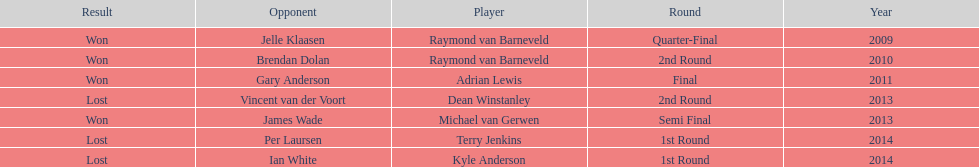What was the names of all the players? Raymond van Barneveld, Raymond van Barneveld, Adrian Lewis, Dean Winstanley, Michael van Gerwen, Terry Jenkins, Kyle Anderson. What years were the championship offered? 2009, 2010, 2011, 2013, 2013, 2014, 2014. Of these, who played in 2011? Adrian Lewis. 